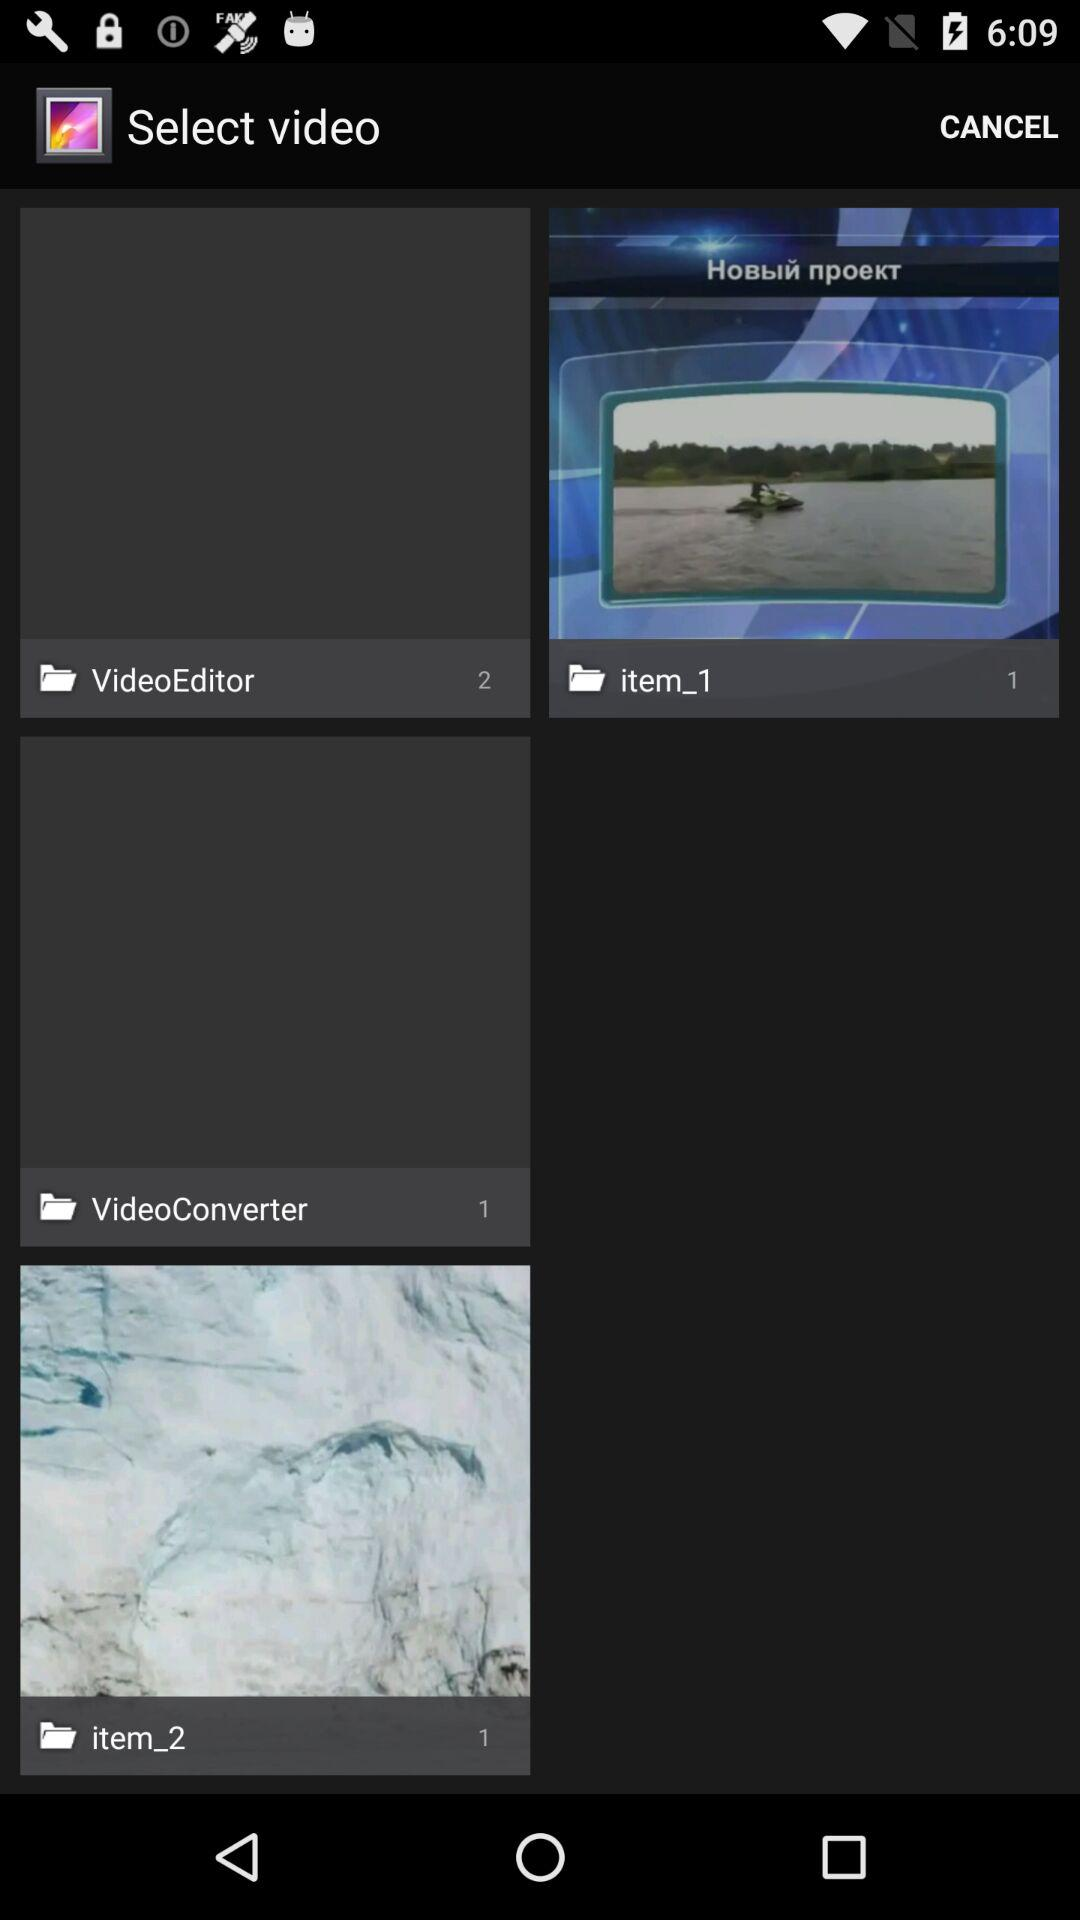How many images are there in the "item_1" album? There is 1 image in the "item_1" album. 